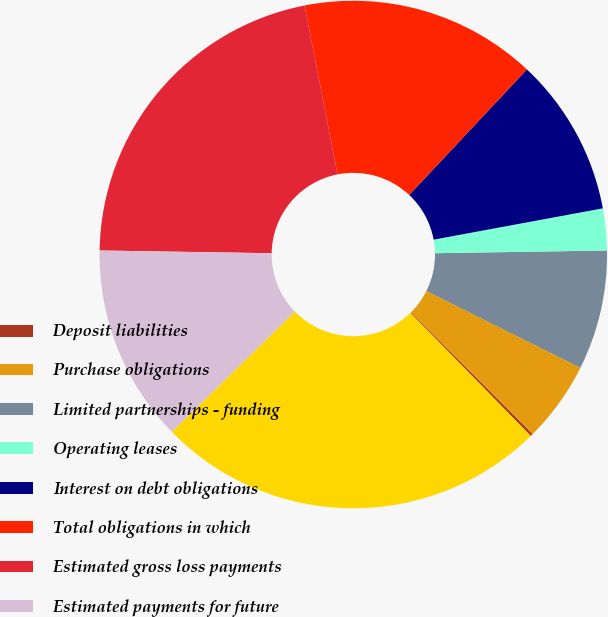Convert chart to OTSL. <chart><loc_0><loc_0><loc_500><loc_500><pie_chart><fcel>Deposit liabilities<fcel>Purchase obligations<fcel>Limited partnerships - funding<fcel>Operating leases<fcel>Interest on debt obligations<fcel>Total obligations in which<fcel>Estimated gross loss payments<fcel>Estimated payments for future<fcel>Total contractual obligations<nl><fcel>0.17%<fcel>5.14%<fcel>7.62%<fcel>2.66%<fcel>10.1%<fcel>15.07%<fcel>21.67%<fcel>12.58%<fcel>25.0%<nl></chart> 